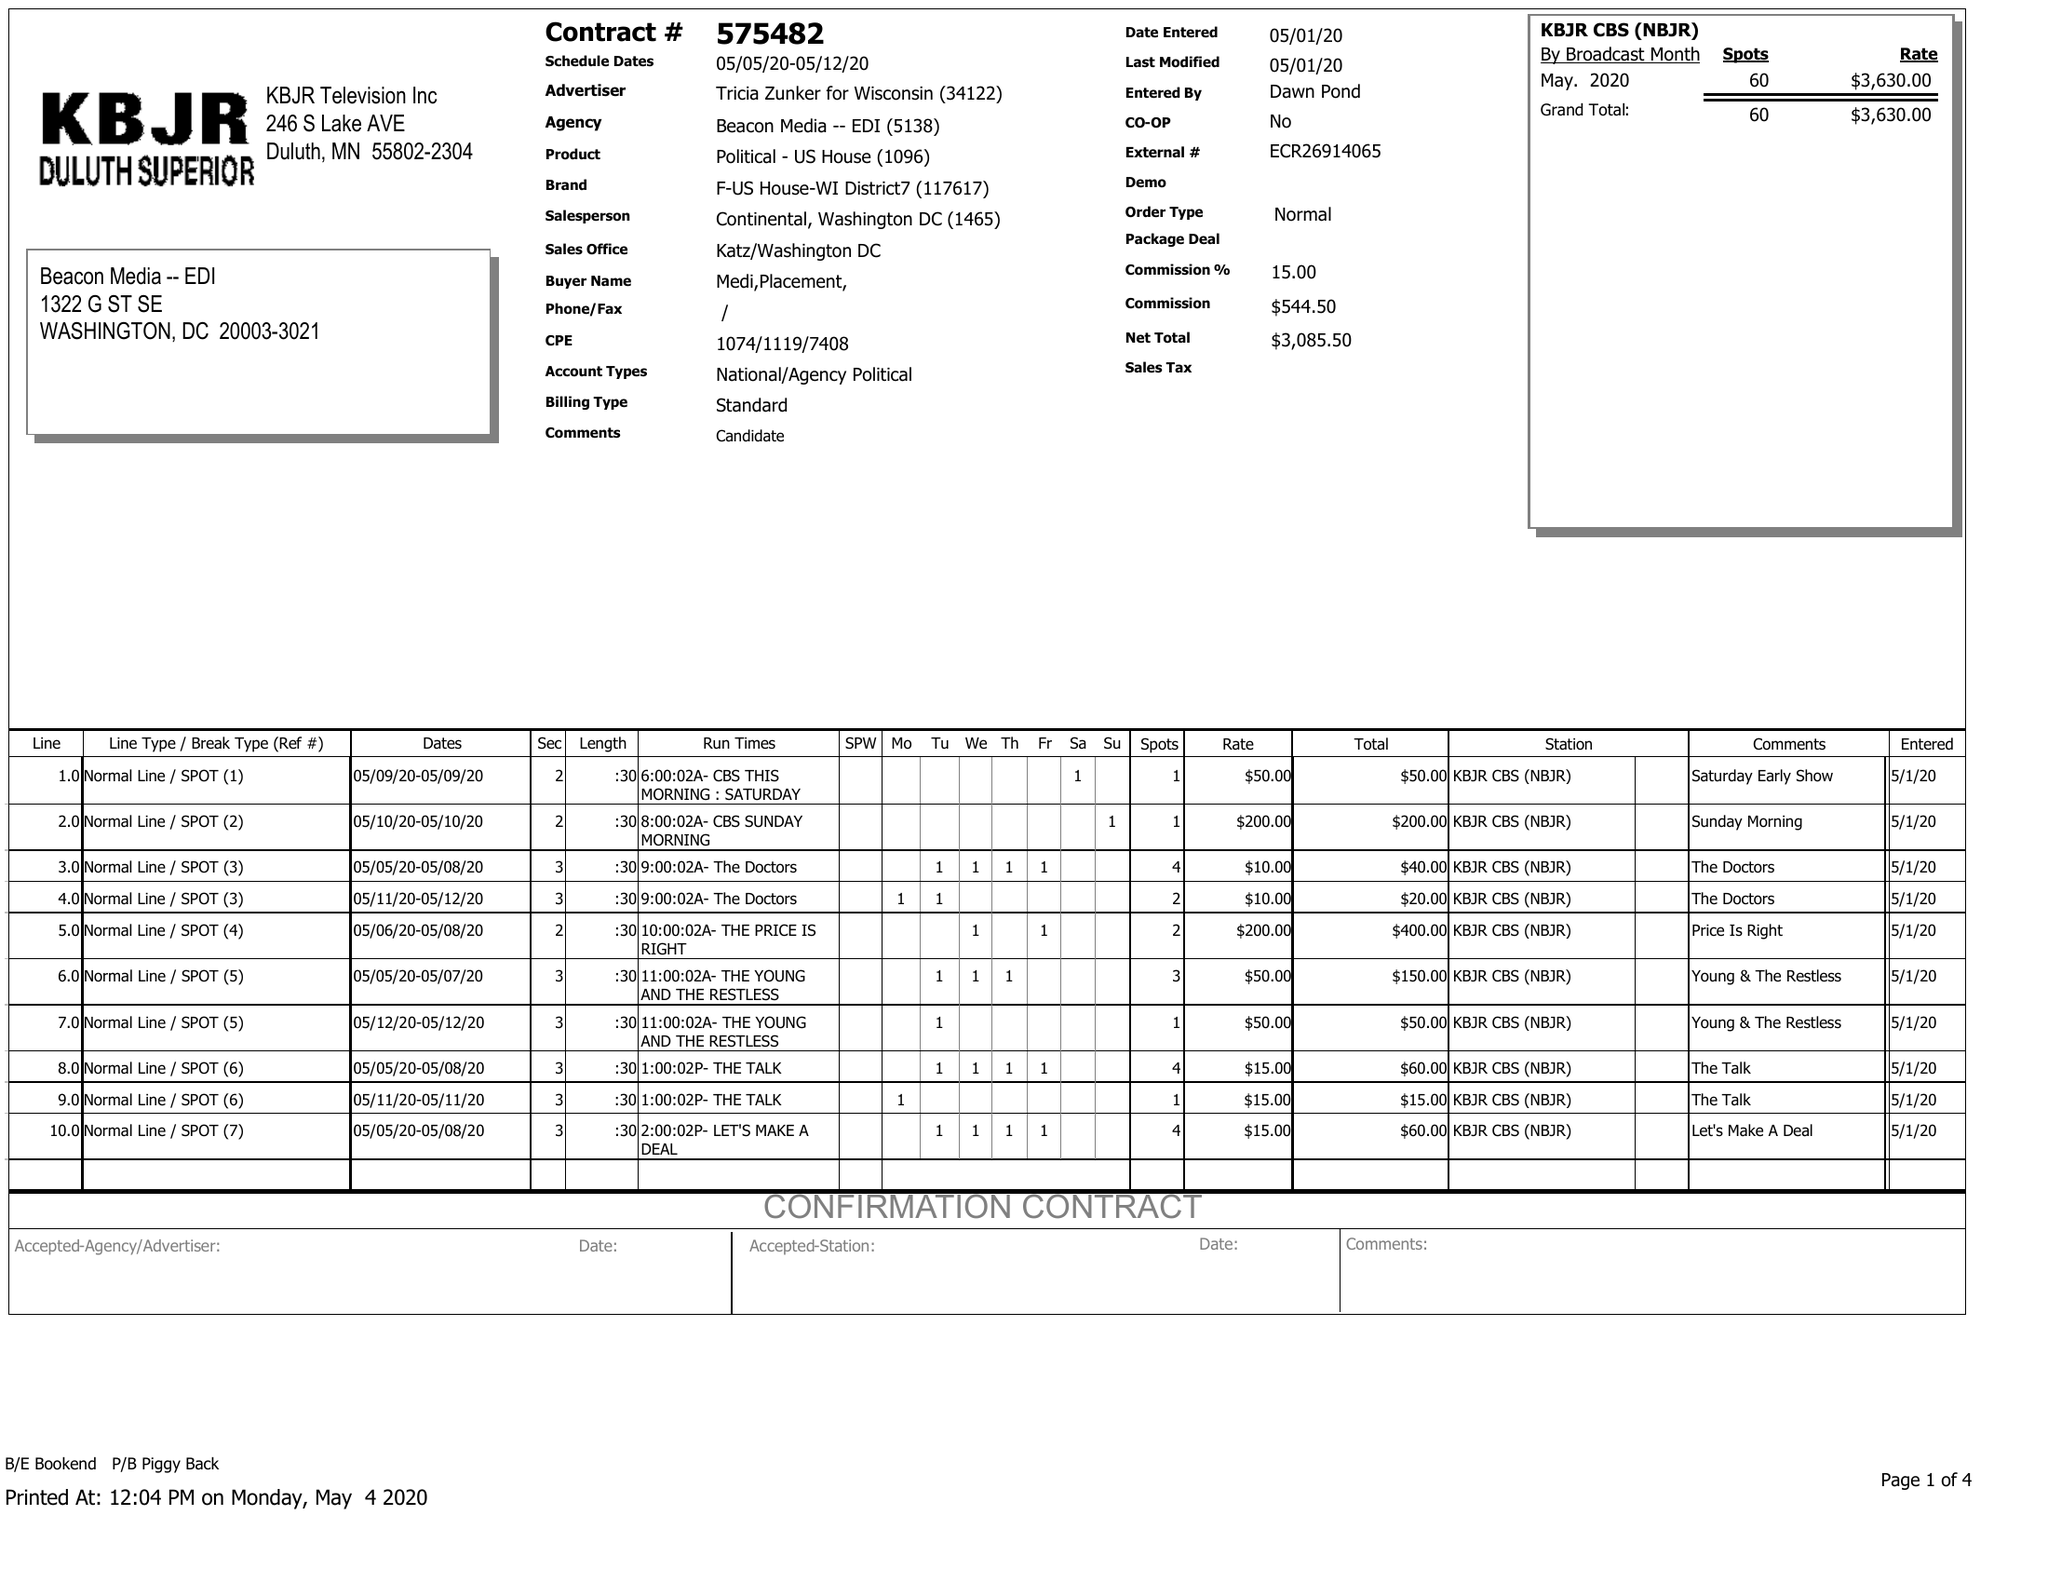What is the value for the advertiser?
Answer the question using a single word or phrase. TRICIA ZUNKER FOR WISCONSIN 